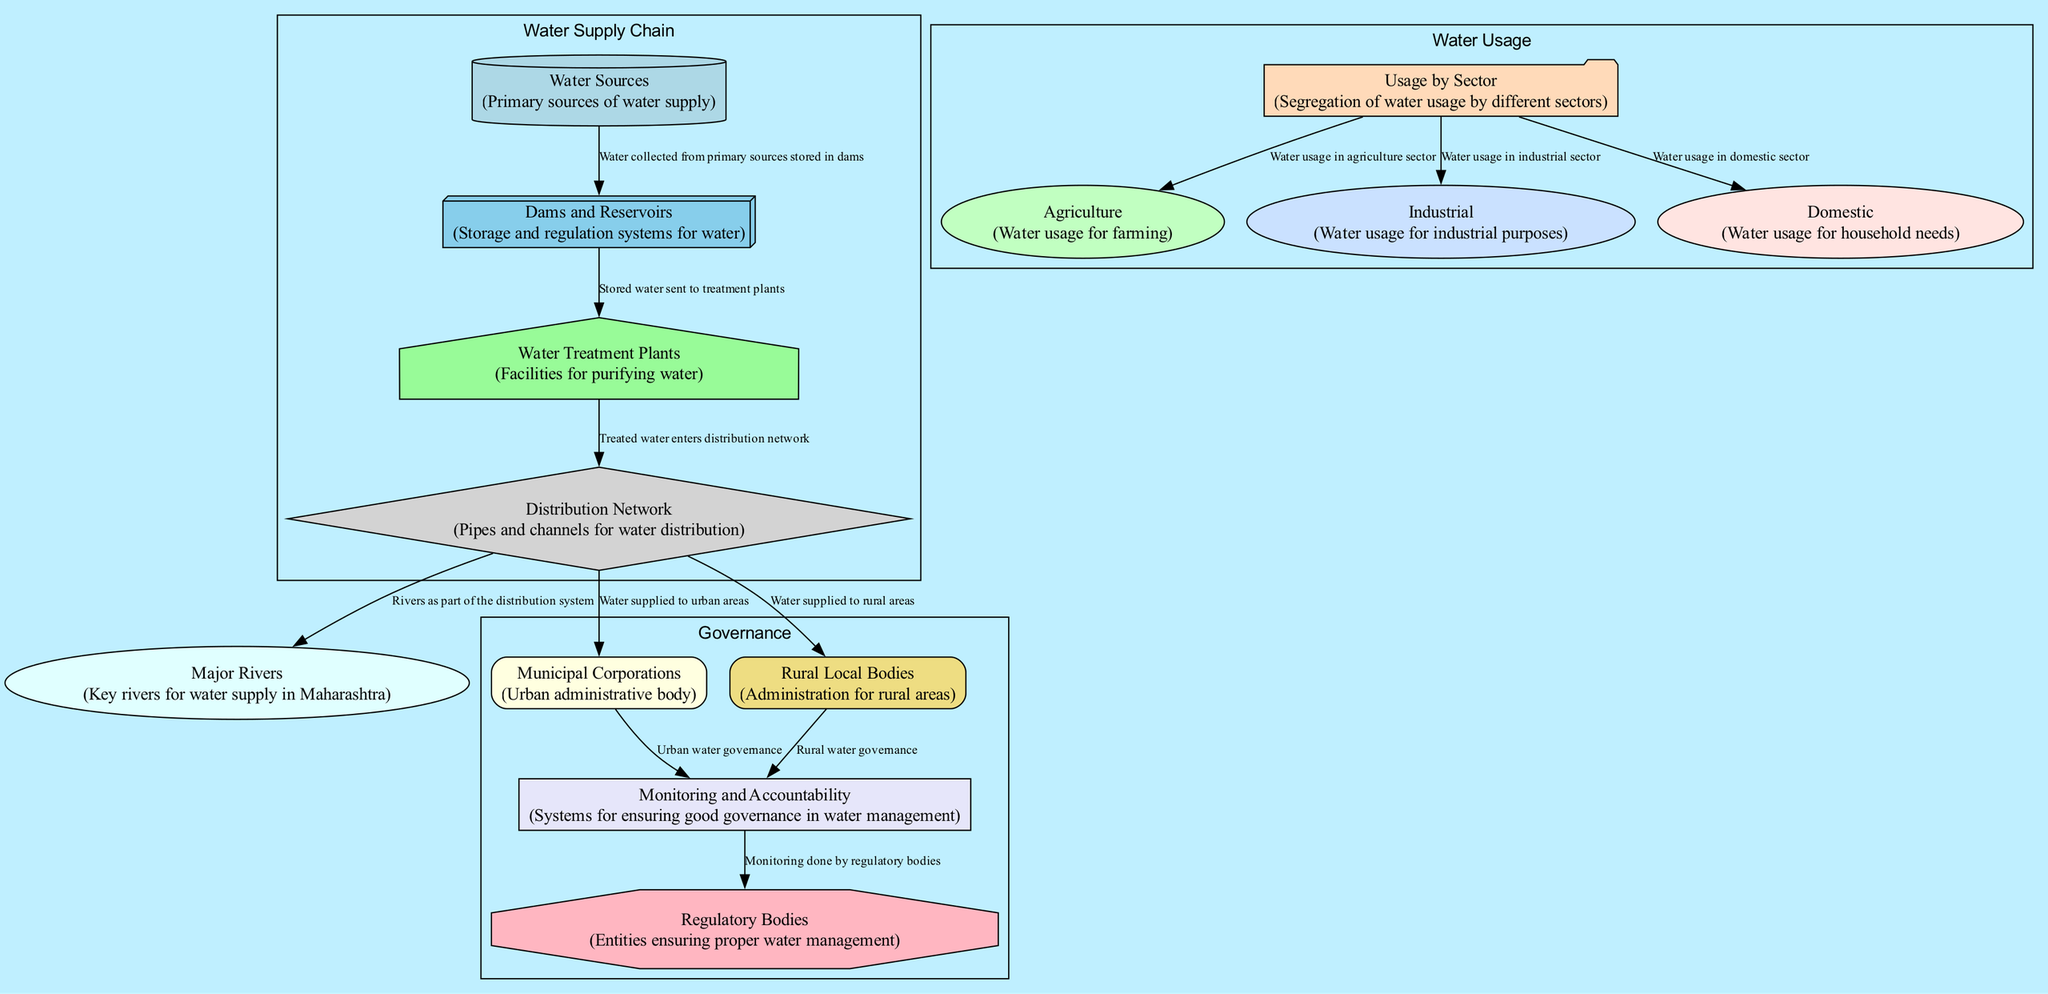What are the major water sources in Maharashtra? The diagram indicates "Water Sources" as a primary node. Since it is a primary source of water supply, it's clear that it is one of the major sources for the state.
Answer: Water Sources How many nodes represent water usage by sector? The diagram includes three specific nodes under "Usage by Sector": Agriculture, Industrial, and Domestic. Therefore, the total count of these nodes gives the answer.
Answer: 3 How is water treated before distribution? The diagram shows that stored water from Dams and Reservoirs is sent to Water Treatment Plants. This clearly indicates that treatment occurs after water is stored.
Answer: Water Treatment Plants Which sectors are indicated for water usage? Based on the diagram, the sectors for water usage are specified as Agriculture, Industrial, and Domestic, which are directly connected to the "Usage by Sector" node.
Answer: Agriculture, Industrial, Domestic What is the flow of treated water in the distribution network? The diagram highlights that treated water from Water Treatment Plants enters the Distribution Network and then proceeds to both Municipal Corporations and Rural Local Bodies for distribution.
Answer: Municipal Corporations and Rural Local Bodies What role do regulatory bodies play in water management? According to the diagram, Regulatory Bodies are connected to Monitoring and Accountability. This indicates that these bodies are responsible for ensuring effective monitoring of water governance and management.
Answer: Monitoring Which entities are responsible for urban and rural water governance? The diagram clearly shows Municipal Corporations for urban governance and Rural Local Bodies for rural governance, both linked to the Monitoring and Accountability node, indicating their role in governance.
Answer: Municipal Corporations, Rural Local Bodies How is water collected from primary sources utilized? The diagram specifies that water collected from primary sources is stored in Dams and Reservoirs before proceeding to Water Treatment Plants. This outlines a sequential flow starting from collection to treatment.
Answer: Stored in Dams Which node is linked with both urban and rural areas in the distribution process? The node Distribution Network links both Municipal Corporations (for urban areas) and Rural Local Bodies (for rural areas), indicating that it provides water to both types of administrative bodies.
Answer: Distribution Network 